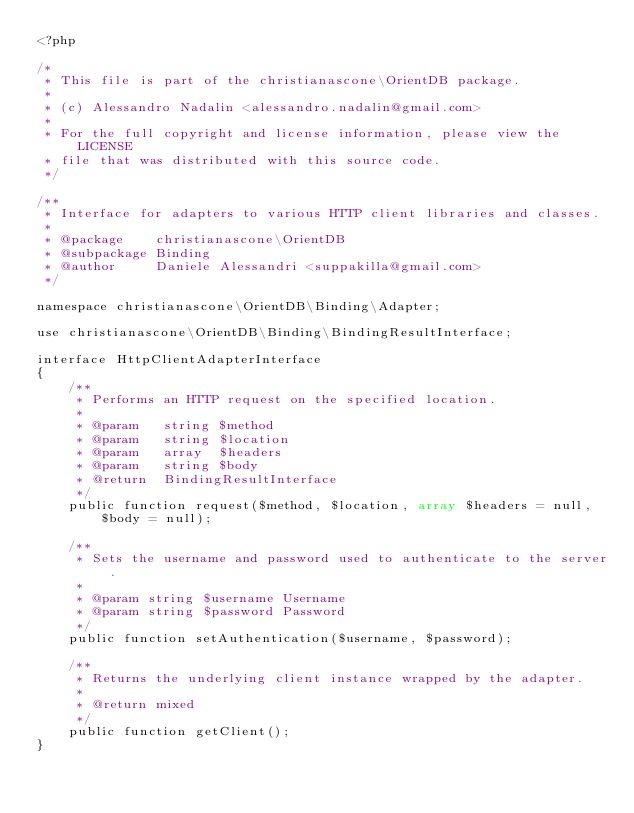<code> <loc_0><loc_0><loc_500><loc_500><_PHP_><?php

/*
 * This file is part of the christianascone\OrientDB package.
 *
 * (c) Alessandro Nadalin <alessandro.nadalin@gmail.com>
 *
 * For the full copyright and license information, please view the LICENSE
 * file that was distributed with this source code.
 */

/**
 * Interface for adapters to various HTTP client libraries and classes.
 *
 * @package    christianascone\OrientDB
 * @subpackage Binding
 * @author     Daniele Alessandri <suppakilla@gmail.com>
 */

namespace christianascone\OrientDB\Binding\Adapter;

use christianascone\OrientDB\Binding\BindingResultInterface;

interface HttpClientAdapterInterface
{
    /**
     * Performs an HTTP request on the specified location.
     *
     * @param   string $method
     * @param   string $location
     * @param   array  $headers
     * @param   string $body
     * @return  BindingResultInterface
     */
    public function request($method, $location, array $headers = null, $body = null);

    /**
     * Sets the username and password used to authenticate to the server.
     *
     * @param string $username Username
     * @param string $password Password
     */
    public function setAuthentication($username, $password);

    /**
     * Returns the underlying client instance wrapped by the adapter.
     *
     * @return mixed
     */
    public function getClient();
}
</code> 